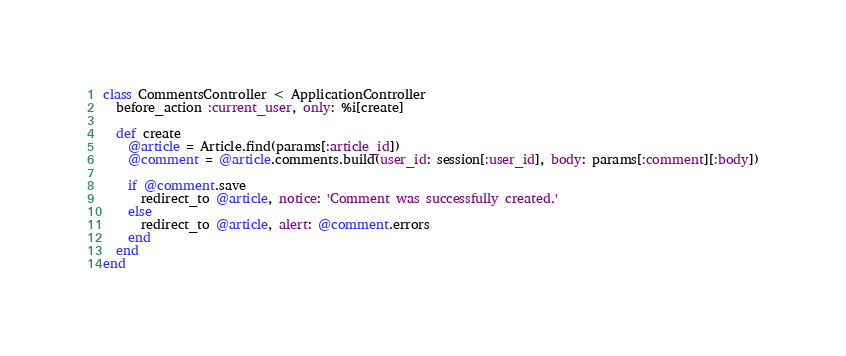<code> <loc_0><loc_0><loc_500><loc_500><_Ruby_>class CommentsController < ApplicationController
  before_action :current_user, only: %i[create]

  def create
    @article = Article.find(params[:article_id])
    @comment = @article.comments.build(user_id: session[:user_id], body: params[:comment][:body])

    if @comment.save
      redirect_to @article, notice: 'Comment was successfully created.'
    else
      redirect_to @article, alert: @comment.errors
    end
  end
end
</code> 